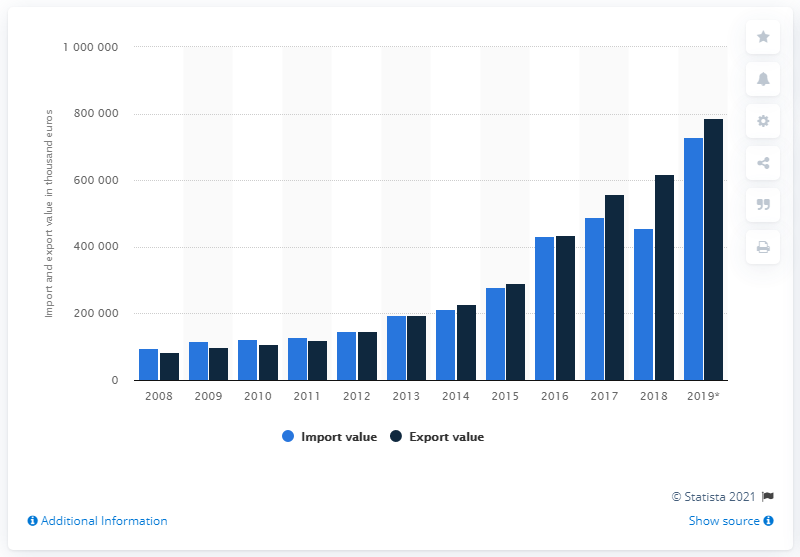List a handful of essential elements in this visual. In 2019, the export value of avocados to the Netherlands was approximately 785,772 US dollars. 